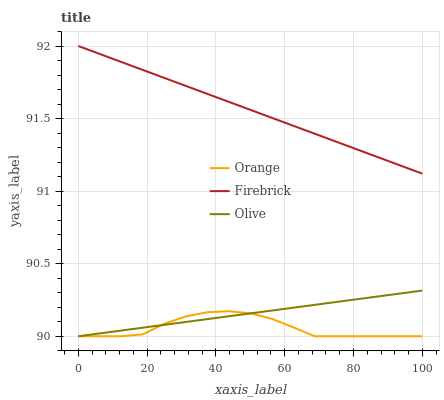Does Orange have the minimum area under the curve?
Answer yes or no. Yes. Does Firebrick have the maximum area under the curve?
Answer yes or no. Yes. Does Olive have the minimum area under the curve?
Answer yes or no. No. Does Olive have the maximum area under the curve?
Answer yes or no. No. Is Olive the smoothest?
Answer yes or no. Yes. Is Orange the roughest?
Answer yes or no. Yes. Is Firebrick the smoothest?
Answer yes or no. No. Is Firebrick the roughest?
Answer yes or no. No. Does Orange have the lowest value?
Answer yes or no. Yes. Does Firebrick have the lowest value?
Answer yes or no. No. Does Firebrick have the highest value?
Answer yes or no. Yes. Does Olive have the highest value?
Answer yes or no. No. Is Olive less than Firebrick?
Answer yes or no. Yes. Is Firebrick greater than Olive?
Answer yes or no. Yes. Does Orange intersect Olive?
Answer yes or no. Yes. Is Orange less than Olive?
Answer yes or no. No. Is Orange greater than Olive?
Answer yes or no. No. Does Olive intersect Firebrick?
Answer yes or no. No. 